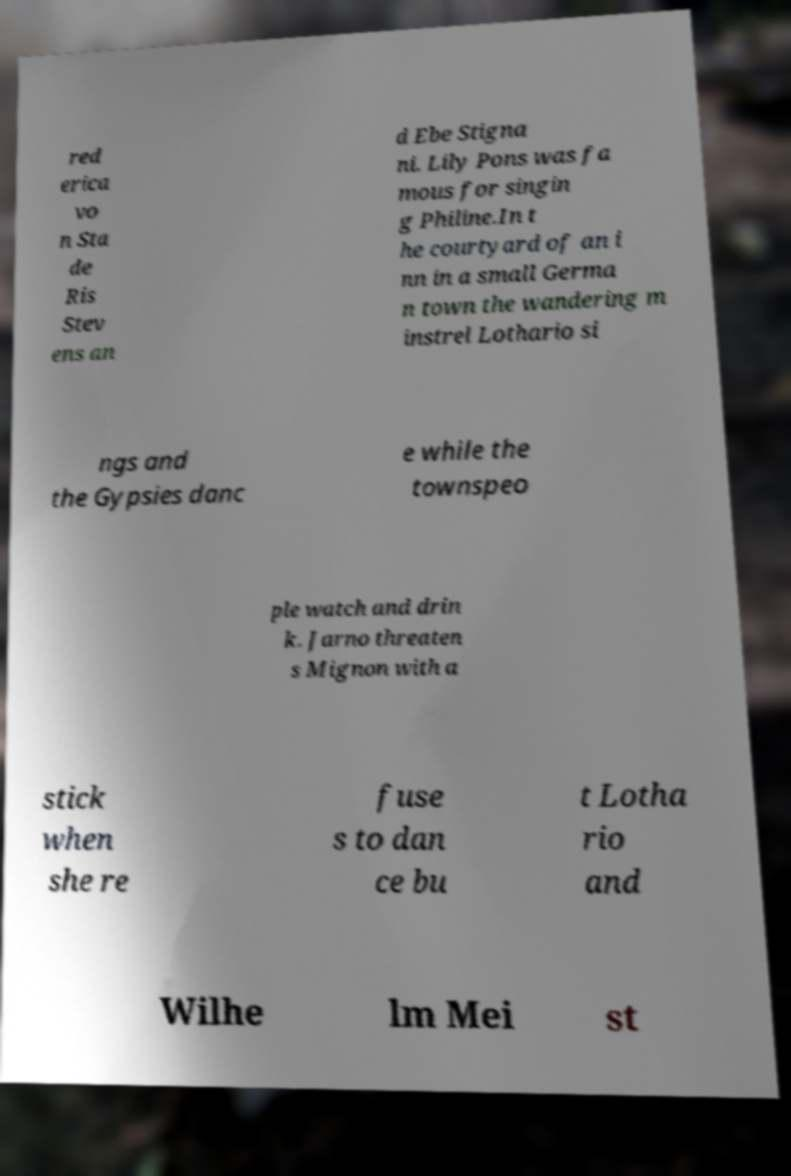Could you extract and type out the text from this image? red erica vo n Sta de Ris Stev ens an d Ebe Stigna ni. Lily Pons was fa mous for singin g Philine.In t he courtyard of an i nn in a small Germa n town the wandering m instrel Lothario si ngs and the Gypsies danc e while the townspeo ple watch and drin k. Jarno threaten s Mignon with a stick when she re fuse s to dan ce bu t Lotha rio and Wilhe lm Mei st 